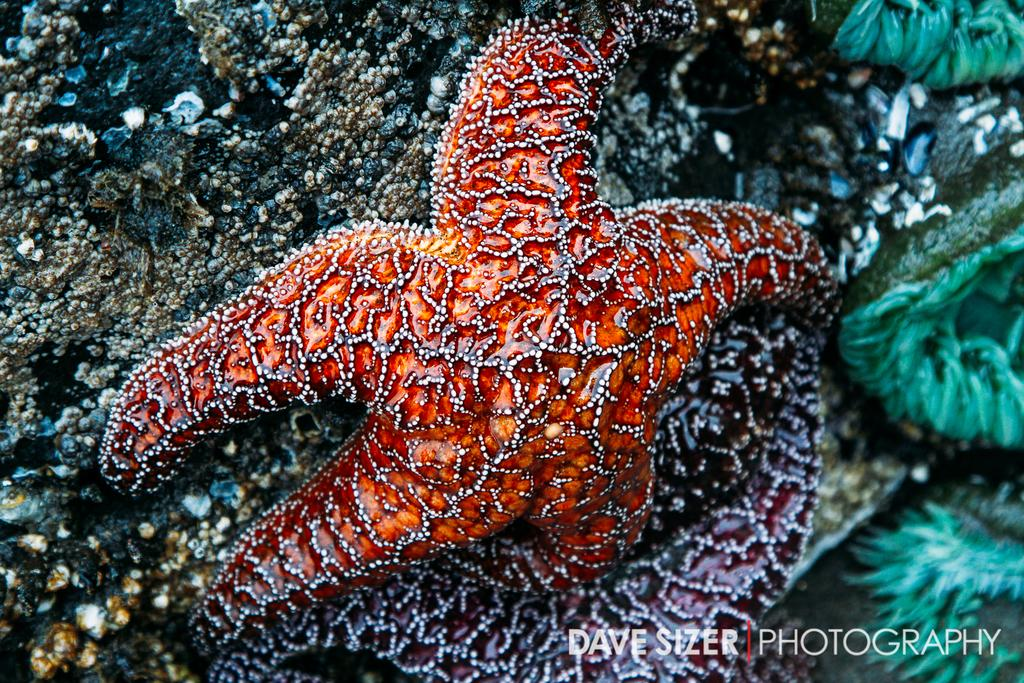What is the main subject of the image? The main subject of the image is a starfish. Where is the starfish located in the image? The starfish is in the middle of the image. What type of vegetation can be seen on the right side of the image? There are sea plants on the right side of the image. What is the starfish resting on in the image? The starfish is on a stone. What type of discovery was made by the parent in the image? There is no mention of a discovery or a parent in the image; it features a starfish on a stone with sea plants nearby. 